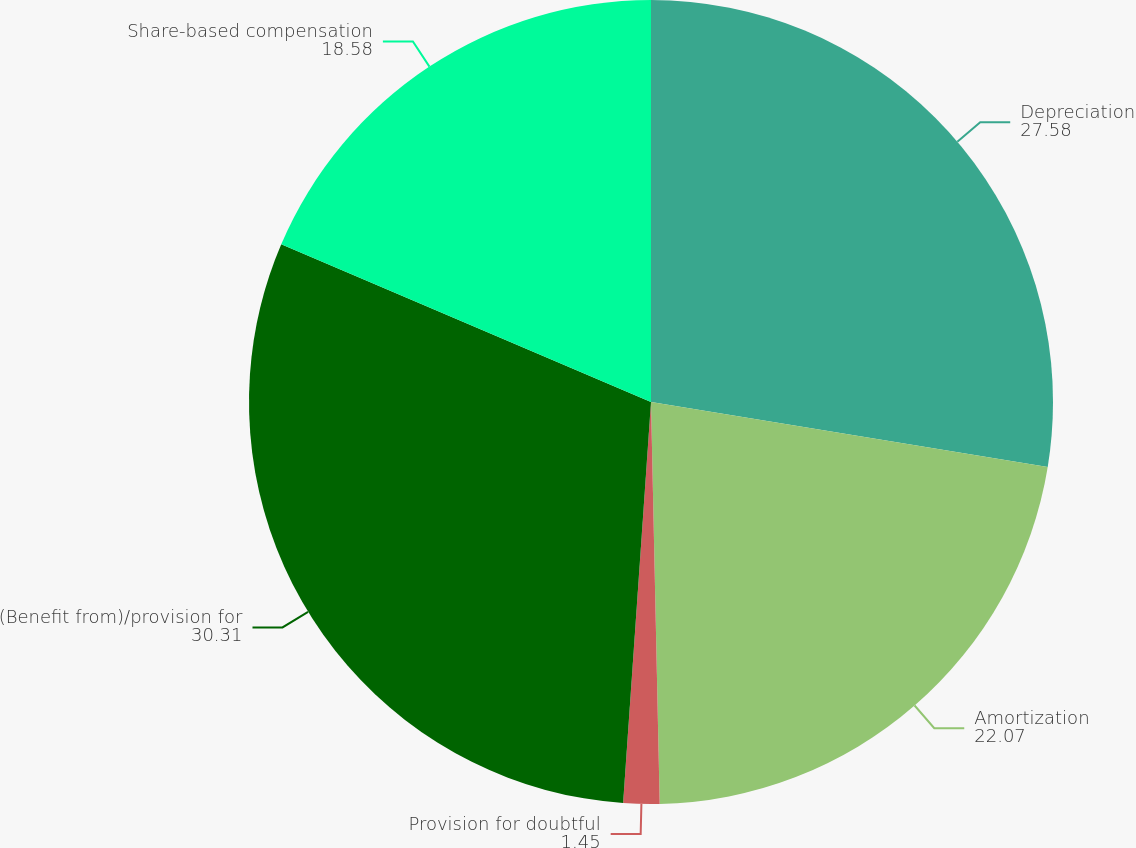Convert chart to OTSL. <chart><loc_0><loc_0><loc_500><loc_500><pie_chart><fcel>Depreciation<fcel>Amortization<fcel>Provision for doubtful<fcel>(Benefit from)/provision for<fcel>Share-based compensation<nl><fcel>27.58%<fcel>22.07%<fcel>1.45%<fcel>30.31%<fcel>18.58%<nl></chart> 